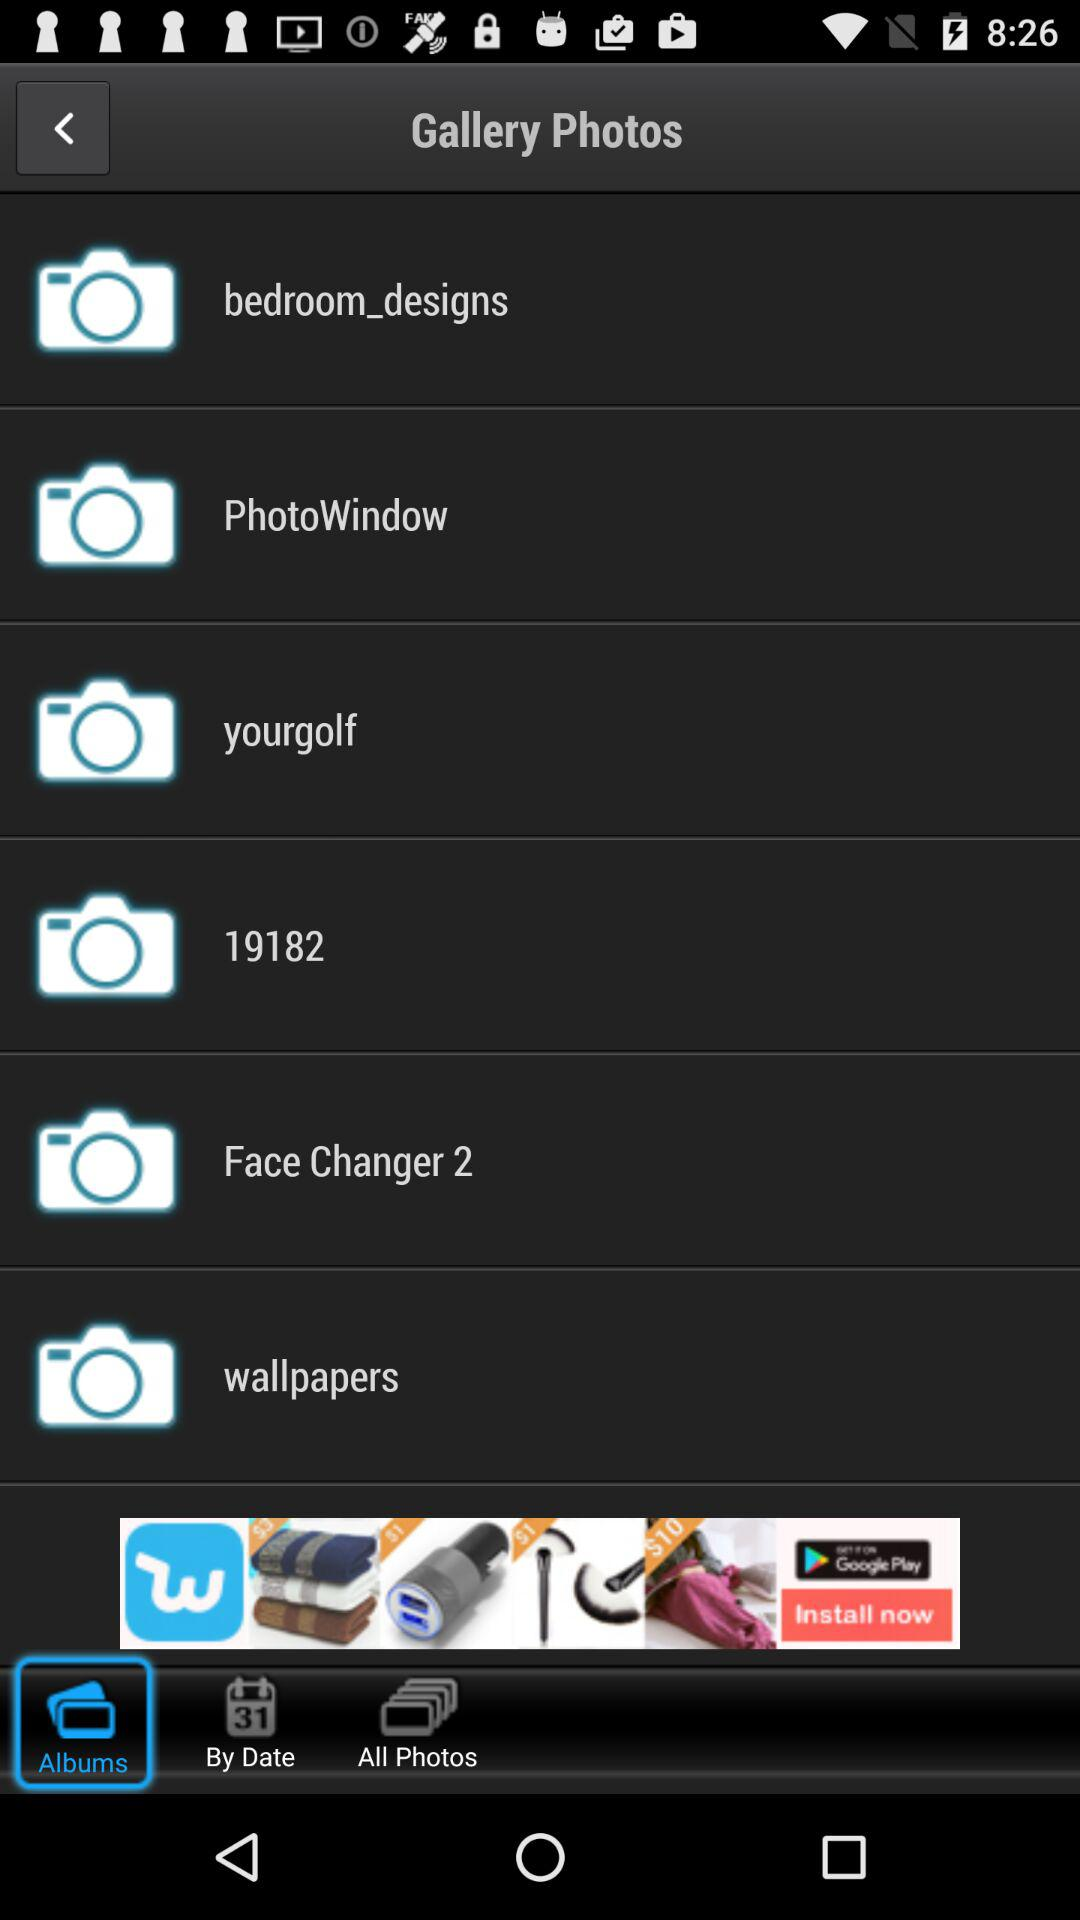Which tab is selected? The selected tab is "Albums". 